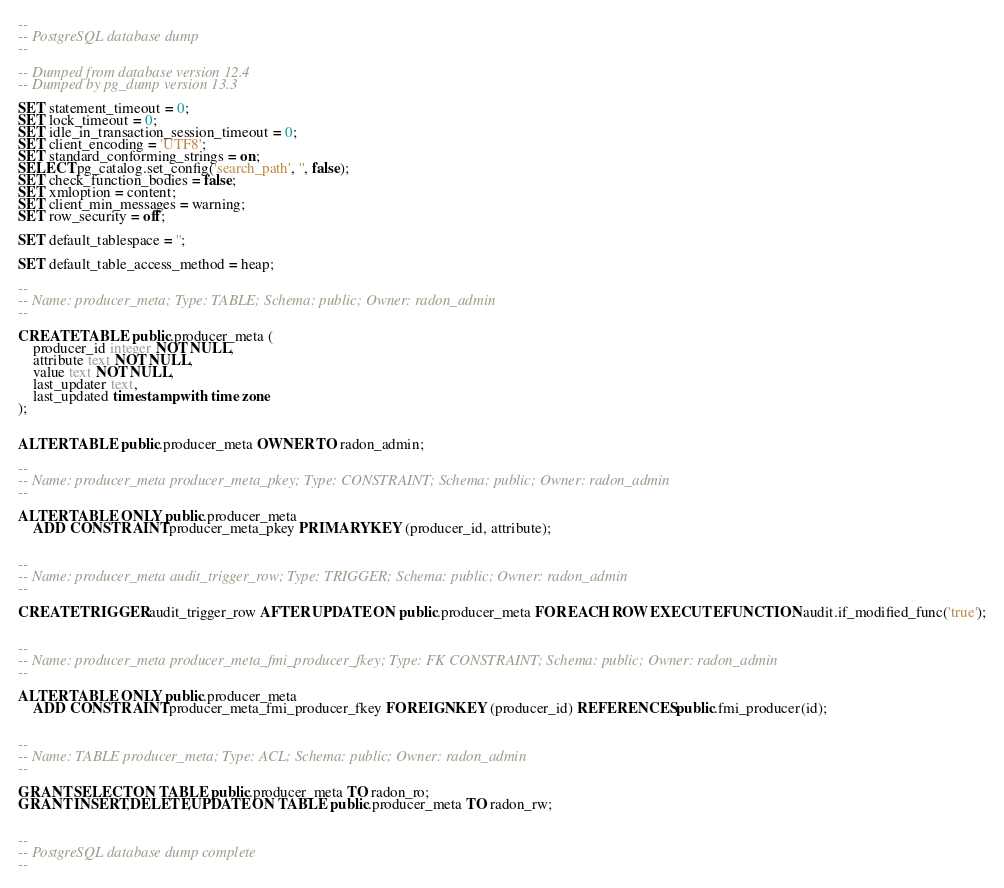Convert code to text. <code><loc_0><loc_0><loc_500><loc_500><_SQL_>--
-- PostgreSQL database dump
--

-- Dumped from database version 12.4
-- Dumped by pg_dump version 13.3

SET statement_timeout = 0;
SET lock_timeout = 0;
SET idle_in_transaction_session_timeout = 0;
SET client_encoding = 'UTF8';
SET standard_conforming_strings = on;
SELECT pg_catalog.set_config('search_path', '', false);
SET check_function_bodies = false;
SET xmloption = content;
SET client_min_messages = warning;
SET row_security = off;

SET default_tablespace = '';

SET default_table_access_method = heap;

--
-- Name: producer_meta; Type: TABLE; Schema: public; Owner: radon_admin
--

CREATE TABLE public.producer_meta (
    producer_id integer NOT NULL,
    attribute text NOT NULL,
    value text NOT NULL,
    last_updater text,
    last_updated timestamp with time zone
);


ALTER TABLE public.producer_meta OWNER TO radon_admin;

--
-- Name: producer_meta producer_meta_pkey; Type: CONSTRAINT; Schema: public; Owner: radon_admin
--

ALTER TABLE ONLY public.producer_meta
    ADD CONSTRAINT producer_meta_pkey PRIMARY KEY (producer_id, attribute);


--
-- Name: producer_meta audit_trigger_row; Type: TRIGGER; Schema: public; Owner: radon_admin
--

CREATE TRIGGER audit_trigger_row AFTER UPDATE ON public.producer_meta FOR EACH ROW EXECUTE FUNCTION audit.if_modified_func('true');


--
-- Name: producer_meta producer_meta_fmi_producer_fkey; Type: FK CONSTRAINT; Schema: public; Owner: radon_admin
--

ALTER TABLE ONLY public.producer_meta
    ADD CONSTRAINT producer_meta_fmi_producer_fkey FOREIGN KEY (producer_id) REFERENCES public.fmi_producer(id);


--
-- Name: TABLE producer_meta; Type: ACL; Schema: public; Owner: radon_admin
--

GRANT SELECT ON TABLE public.producer_meta TO radon_ro;
GRANT INSERT,DELETE,UPDATE ON TABLE public.producer_meta TO radon_rw;


--
-- PostgreSQL database dump complete
--

</code> 